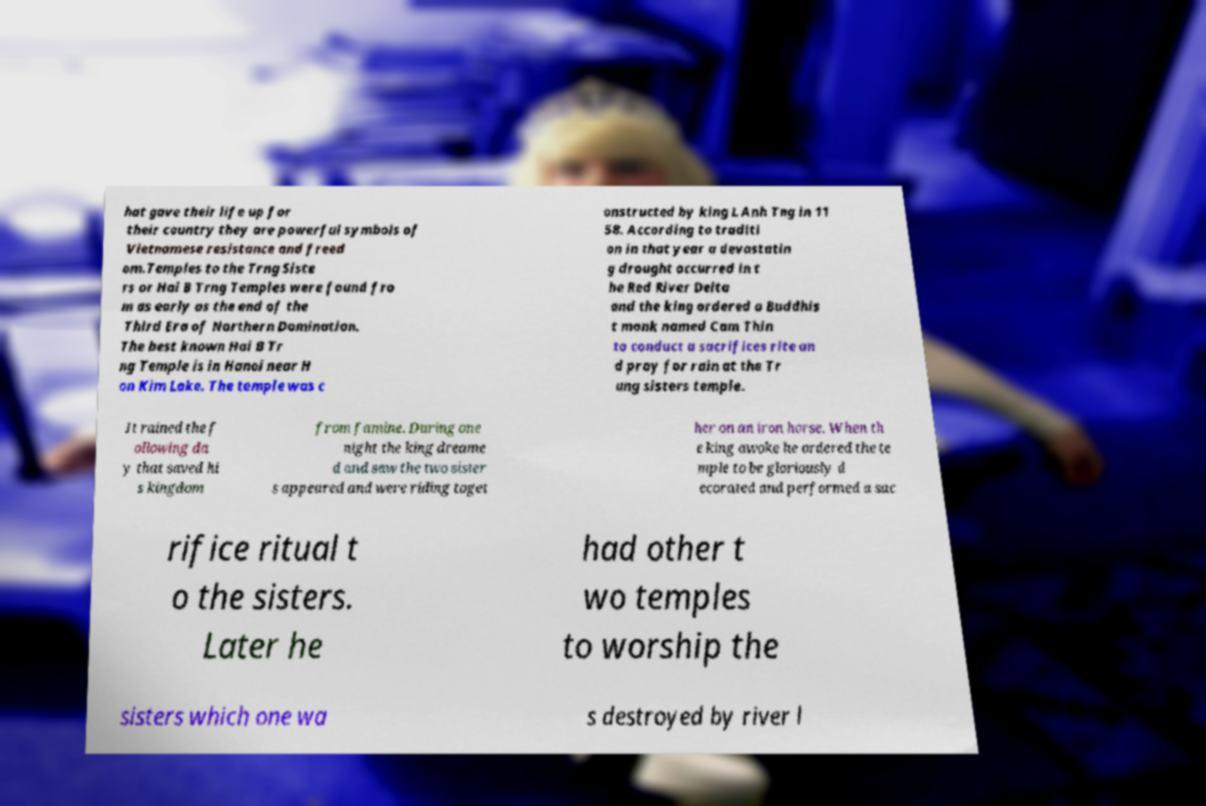Could you extract and type out the text from this image? hat gave their life up for their country they are powerful symbols of Vietnamese resistance and freed om.Temples to the Trng Siste rs or Hai B Trng Temples were found fro m as early as the end of the Third Era of Northern Domination. The best known Hai B Tr ng Temple is in Hanoi near H on Kim Lake. The temple was c onstructed by king L Anh Tng in 11 58. According to traditi on in that year a devastatin g drought occurred in t he Red River Delta and the king ordered a Buddhis t monk named Cam Thin to conduct a sacrifices rite an d pray for rain at the Tr ung sisters temple. It rained the f ollowing da y that saved hi s kingdom from famine. During one night the king dreame d and saw the two sister s appeared and were riding toget her on an iron horse. When th e king awoke he ordered the te mple to be gloriously d ecorated and performed a sac rifice ritual t o the sisters. Later he had other t wo temples to worship the sisters which one wa s destroyed by river l 